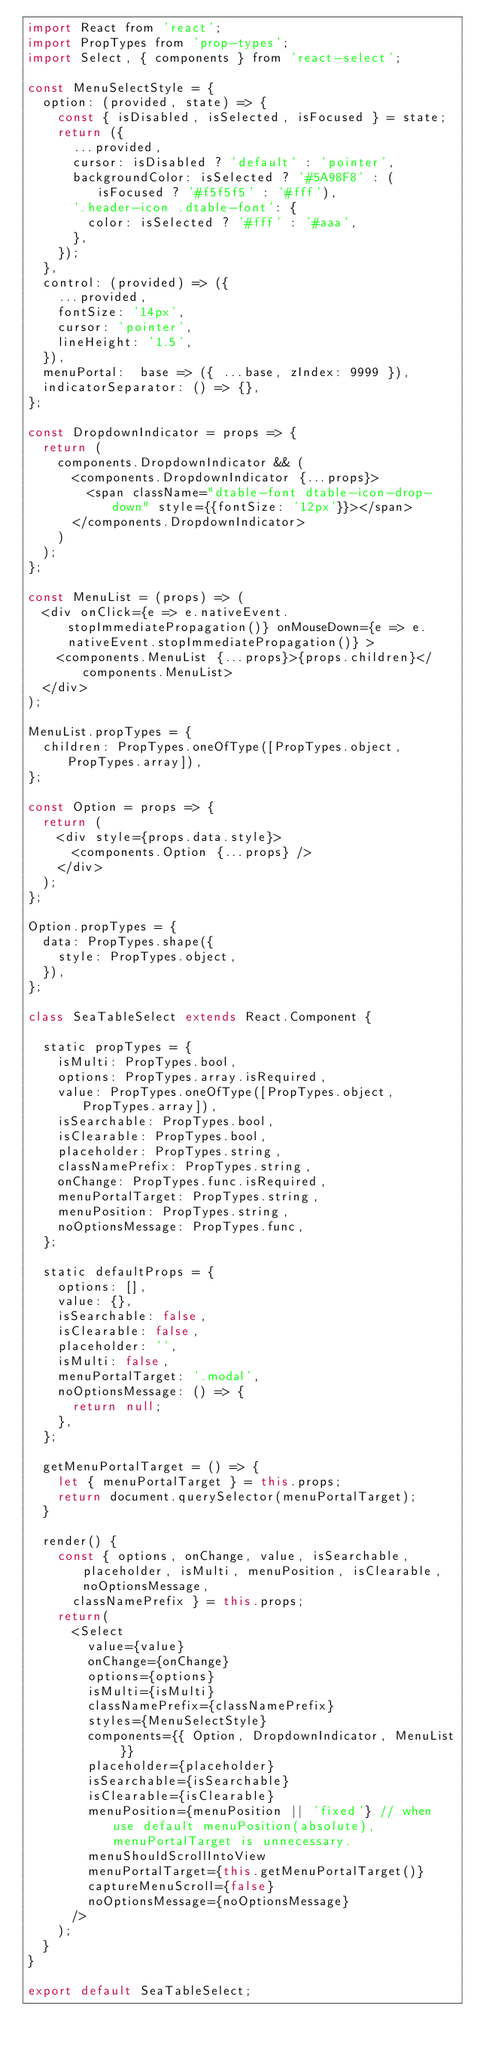Convert code to text. <code><loc_0><loc_0><loc_500><loc_500><_JavaScript_>import React from 'react';
import PropTypes from 'prop-types';
import Select, { components } from 'react-select';

const MenuSelectStyle = {
  option: (provided, state) => {
    const { isDisabled, isSelected, isFocused } = state;
    return ({
      ...provided,
      cursor: isDisabled ? 'default' : 'pointer',
      backgroundColor: isSelected ? '#5A98F8' : (isFocused ? '#f5f5f5' : '#fff'),
      '.header-icon .dtable-font': {
        color: isSelected ? '#fff' : '#aaa',
      },
    });
  },
  control: (provided) => ({
    ...provided,
    fontSize: '14px',
    cursor: 'pointer',
    lineHeight: '1.5',
  }),
  menuPortal:  base => ({ ...base, zIndex: 9999 }),
  indicatorSeparator: () => {},
};

const DropdownIndicator = props => {
  return (
    components.DropdownIndicator && (
      <components.DropdownIndicator {...props}>
        <span className="dtable-font dtable-icon-drop-down" style={{fontSize: '12px'}}></span>
      </components.DropdownIndicator>
    )
  );
};

const MenuList = (props) => (
  <div onClick={e => e.nativeEvent.stopImmediatePropagation()} onMouseDown={e => e.nativeEvent.stopImmediatePropagation()} >
    <components.MenuList {...props}>{props.children}</components.MenuList>
  </div>
);

MenuList.propTypes = {
  children: PropTypes.oneOfType([PropTypes.object, PropTypes.array]),
};

const Option = props => {
  return (
    <div style={props.data.style}>
      <components.Option {...props} />
    </div>
  );
};

Option.propTypes = {
  data: PropTypes.shape({
    style: PropTypes.object,
  }),
};

class SeaTableSelect extends React.Component {

  static propTypes = {
    isMulti: PropTypes.bool,
    options: PropTypes.array.isRequired,
    value: PropTypes.oneOfType([PropTypes.object, PropTypes.array]),
    isSearchable: PropTypes.bool,
    isClearable: PropTypes.bool,
    placeholder: PropTypes.string,
    classNamePrefix: PropTypes.string,
    onChange: PropTypes.func.isRequired,
    menuPortalTarget: PropTypes.string,
    menuPosition: PropTypes.string,
    noOptionsMessage: PropTypes.func,
  };

  static defaultProps = {
    options: [],
    value: {},
    isSearchable: false,
    isClearable: false,
    placeholder: '',
    isMulti: false,
    menuPortalTarget: '.modal',
    noOptionsMessage: () => {
      return null;
    },
  };

  getMenuPortalTarget = () => {
    let { menuPortalTarget } = this.props;
    return document.querySelector(menuPortalTarget);
  }

  render() {
    const { options, onChange, value, isSearchable, placeholder, isMulti, menuPosition, isClearable, noOptionsMessage, 
      classNamePrefix } = this.props;
    return(
      <Select
        value={value}
        onChange={onChange}
        options={options}
        isMulti={isMulti}
        classNamePrefix={classNamePrefix}
        styles={MenuSelectStyle}
        components={{ Option, DropdownIndicator, MenuList }}
        placeholder={placeholder}
        isSearchable={isSearchable}
        isClearable={isClearable}
        menuPosition={menuPosition || 'fixed'} // when use default menuPosition(absolute), menuPortalTarget is unnecessary. 
        menuShouldScrollIntoView
        menuPortalTarget={this.getMenuPortalTarget()}
        captureMenuScroll={false}
        noOptionsMessage={noOptionsMessage}
      />
    ); 
  }
}

export default SeaTableSelect;
</code> 